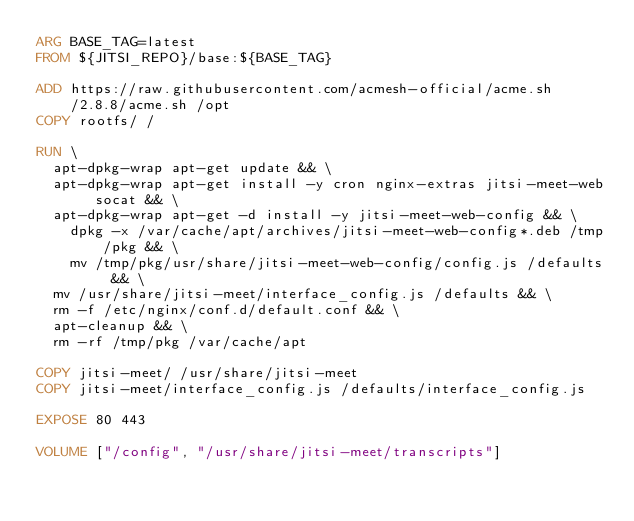<code> <loc_0><loc_0><loc_500><loc_500><_Dockerfile_>ARG BASE_TAG=latest
FROM ${JITSI_REPO}/base:${BASE_TAG}

ADD https://raw.githubusercontent.com/acmesh-official/acme.sh/2.8.8/acme.sh /opt
COPY rootfs/ /

RUN \
	apt-dpkg-wrap apt-get update && \
	apt-dpkg-wrap apt-get install -y cron nginx-extras jitsi-meet-web socat && \
	apt-dpkg-wrap apt-get -d install -y jitsi-meet-web-config && \
    dpkg -x /var/cache/apt/archives/jitsi-meet-web-config*.deb /tmp/pkg && \
    mv /tmp/pkg/usr/share/jitsi-meet-web-config/config.js /defaults && \
	mv /usr/share/jitsi-meet/interface_config.js /defaults && \
	rm -f /etc/nginx/conf.d/default.conf && \
	apt-cleanup && \
	rm -rf /tmp/pkg /var/cache/apt

COPY jitsi-meet/ /usr/share/jitsi-meet
COPY jitsi-meet/interface_config.js /defaults/interface_config.js

EXPOSE 80 443

VOLUME ["/config", "/usr/share/jitsi-meet/transcripts"]
</code> 